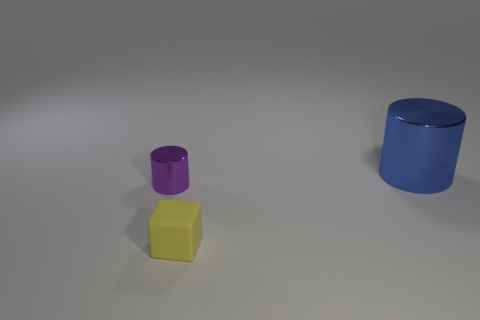Add 1 big matte cylinders. How many objects exist? 4 Subtract all cubes. How many objects are left? 2 Subtract all yellow things. Subtract all purple cylinders. How many objects are left? 1 Add 3 tiny purple metal objects. How many tiny purple metal objects are left? 4 Add 3 large red things. How many large red things exist? 3 Subtract 0 blue blocks. How many objects are left? 3 